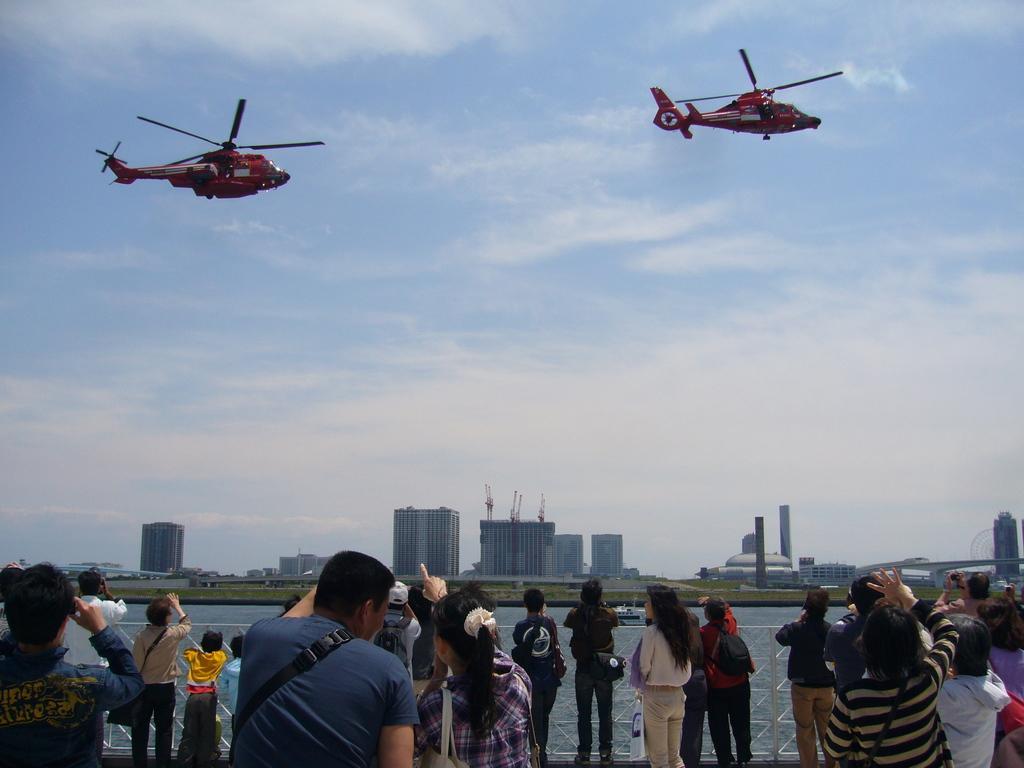In one or two sentences, can you explain what this image depicts? In this picture I can see few people are standing in front of the grills, some planes are in the air, I can see some water, buildings and trees. 